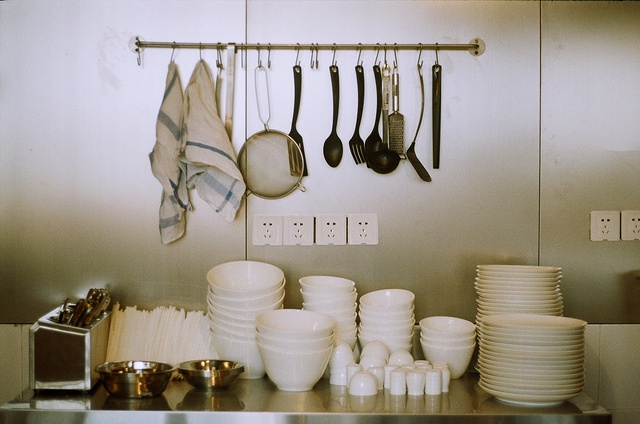Describe the objects in this image and their specific colors. I can see dining table in gray, olive, and black tones, bowl in gray, darkgray, black, and olive tones, bowl in gray, darkgray, and lightgray tones, bowl in gray, darkgray, tan, and olive tones, and bowl in gray, darkgray, and lightgray tones in this image. 